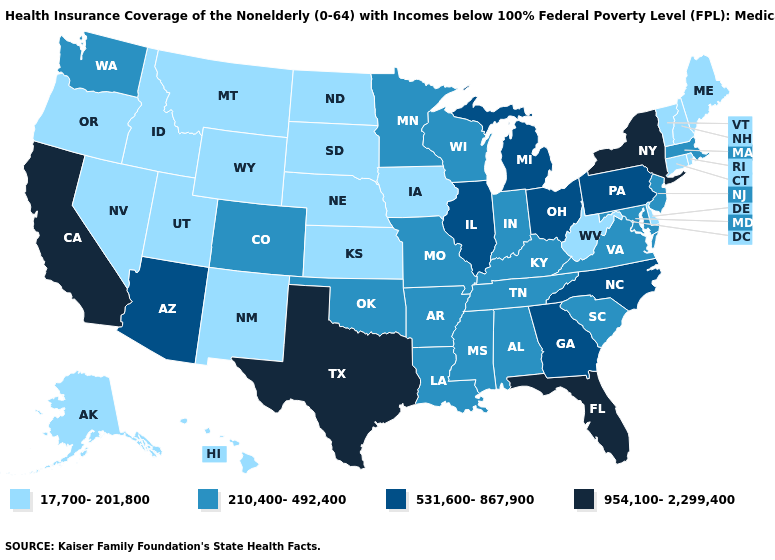Does Kentucky have the lowest value in the South?
Give a very brief answer. No. Does Texas have the highest value in the USA?
Write a very short answer. Yes. What is the lowest value in the West?
Answer briefly. 17,700-201,800. Does Texas have a lower value than Alabama?
Give a very brief answer. No. Which states have the highest value in the USA?
Write a very short answer. California, Florida, New York, Texas. What is the value of Louisiana?
Write a very short answer. 210,400-492,400. Name the states that have a value in the range 954,100-2,299,400?
Concise answer only. California, Florida, New York, Texas. What is the highest value in the USA?
Answer briefly. 954,100-2,299,400. What is the lowest value in the USA?
Give a very brief answer. 17,700-201,800. Which states have the lowest value in the USA?
Short answer required. Alaska, Connecticut, Delaware, Hawaii, Idaho, Iowa, Kansas, Maine, Montana, Nebraska, Nevada, New Hampshire, New Mexico, North Dakota, Oregon, Rhode Island, South Dakota, Utah, Vermont, West Virginia, Wyoming. Which states hav the highest value in the MidWest?
Give a very brief answer. Illinois, Michigan, Ohio. What is the lowest value in the MidWest?
Concise answer only. 17,700-201,800. What is the lowest value in the South?
Be succinct. 17,700-201,800. Name the states that have a value in the range 17,700-201,800?
Be succinct. Alaska, Connecticut, Delaware, Hawaii, Idaho, Iowa, Kansas, Maine, Montana, Nebraska, Nevada, New Hampshire, New Mexico, North Dakota, Oregon, Rhode Island, South Dakota, Utah, Vermont, West Virginia, Wyoming. What is the lowest value in the USA?
Be succinct. 17,700-201,800. 